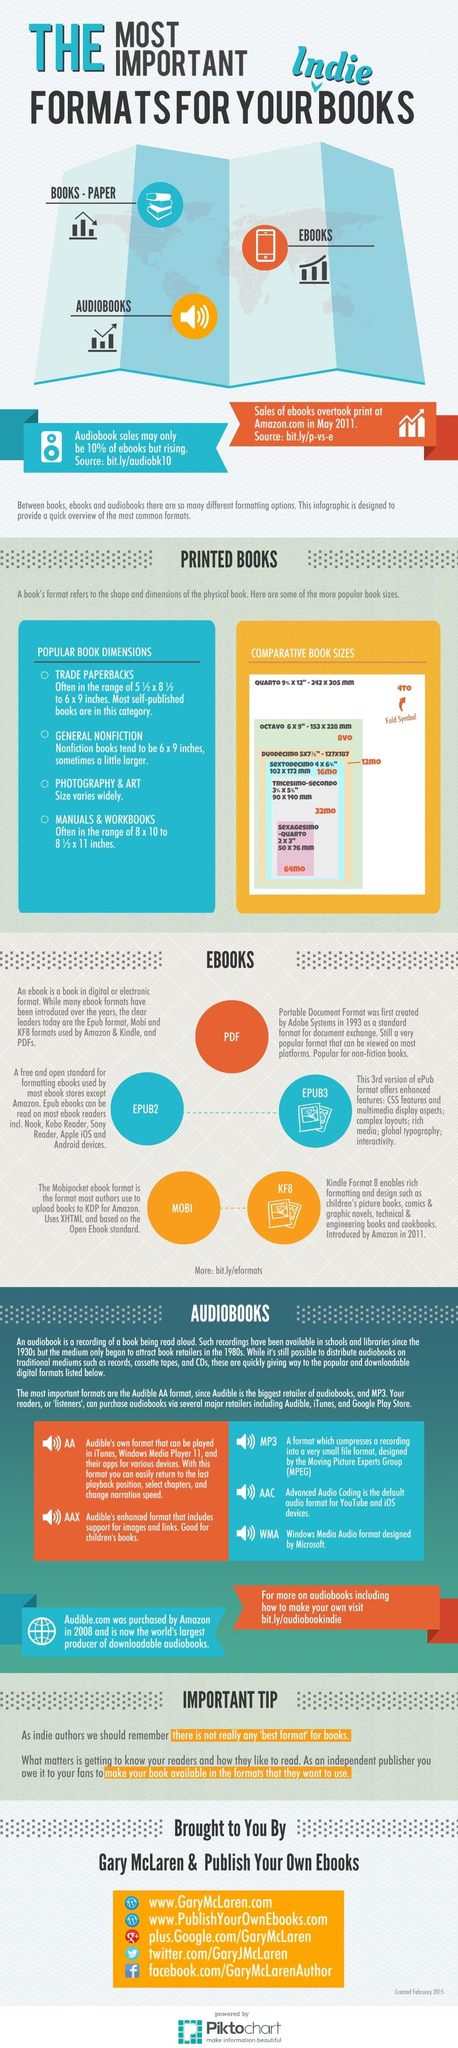Highlight a few significant elements in this photo. MP3, AAC, and WMA are audio book formats that were not developed by Audible. There are 5 types of EBook formats. The type of books that showed a decrease in sales in May 2011 was paper books. 